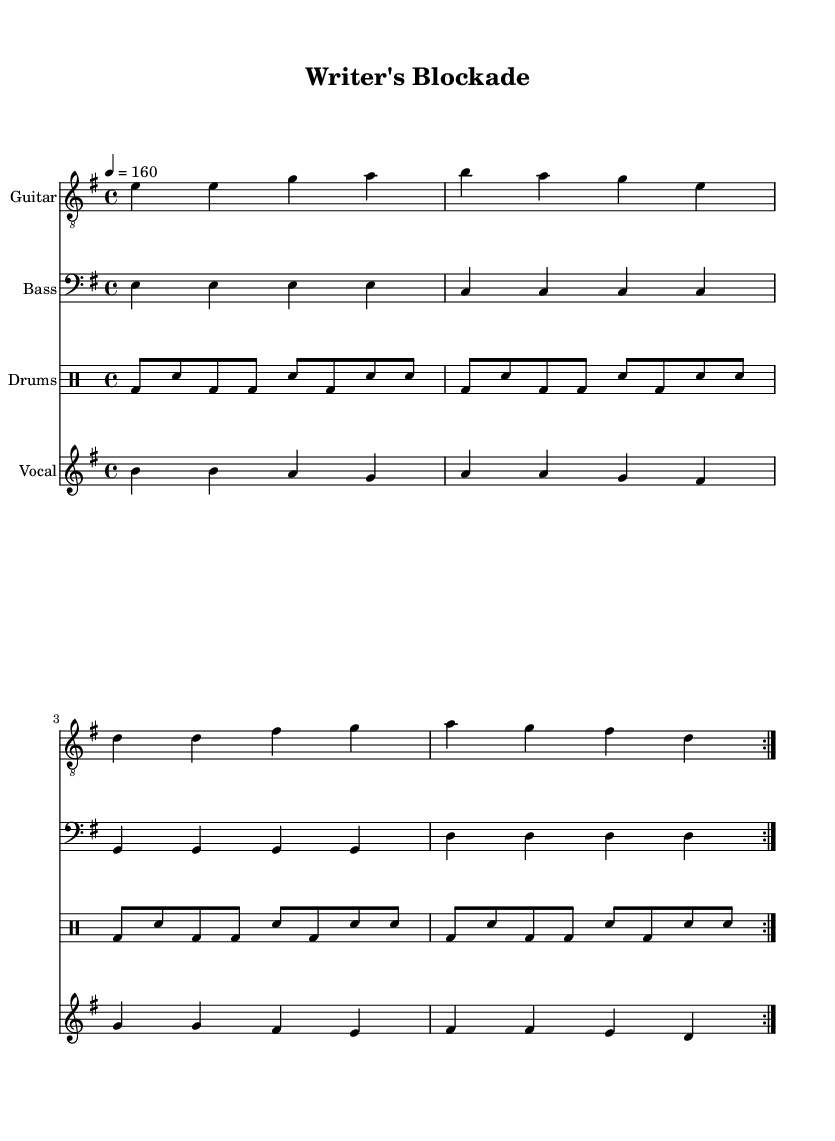What is the key signature of this music? The key signature is indicated at the beginning of the score, showing E minor which has one sharp (F#).
Answer: E minor What is the time signature of this composition? The time signature, found at the beginning of the score, is 4/4, indicating four beats per measure.
Answer: 4/4 What is the tempo marking for this piece? The tempo is specified in the score as "4 = 160," which means there are 160 beats per minute.
Answer: 160 How many measures are in the repeated section for guitar? The repeated section for the guitar consists of four measures which are repeated twice.
Answer: 4 What is the general mood conveyed by the lyrics in this composition? The lyrics reflect feelings of frustration and isolation, which are common themes in introspective punk music.
Answer: Frustration What instruments are used in this composition? The score lists four instruments: guitar, bass, drums, and vocals, indicative of a typical punk band setup.
Answer: Guitar, bass, drums, vocals What lyrical theme is present in this piece? The lyrics discuss the challenges of writer's block and the struggle for self-expression, aligning with the introspective nature of the composition.
Answer: Writer's block and self-expression 